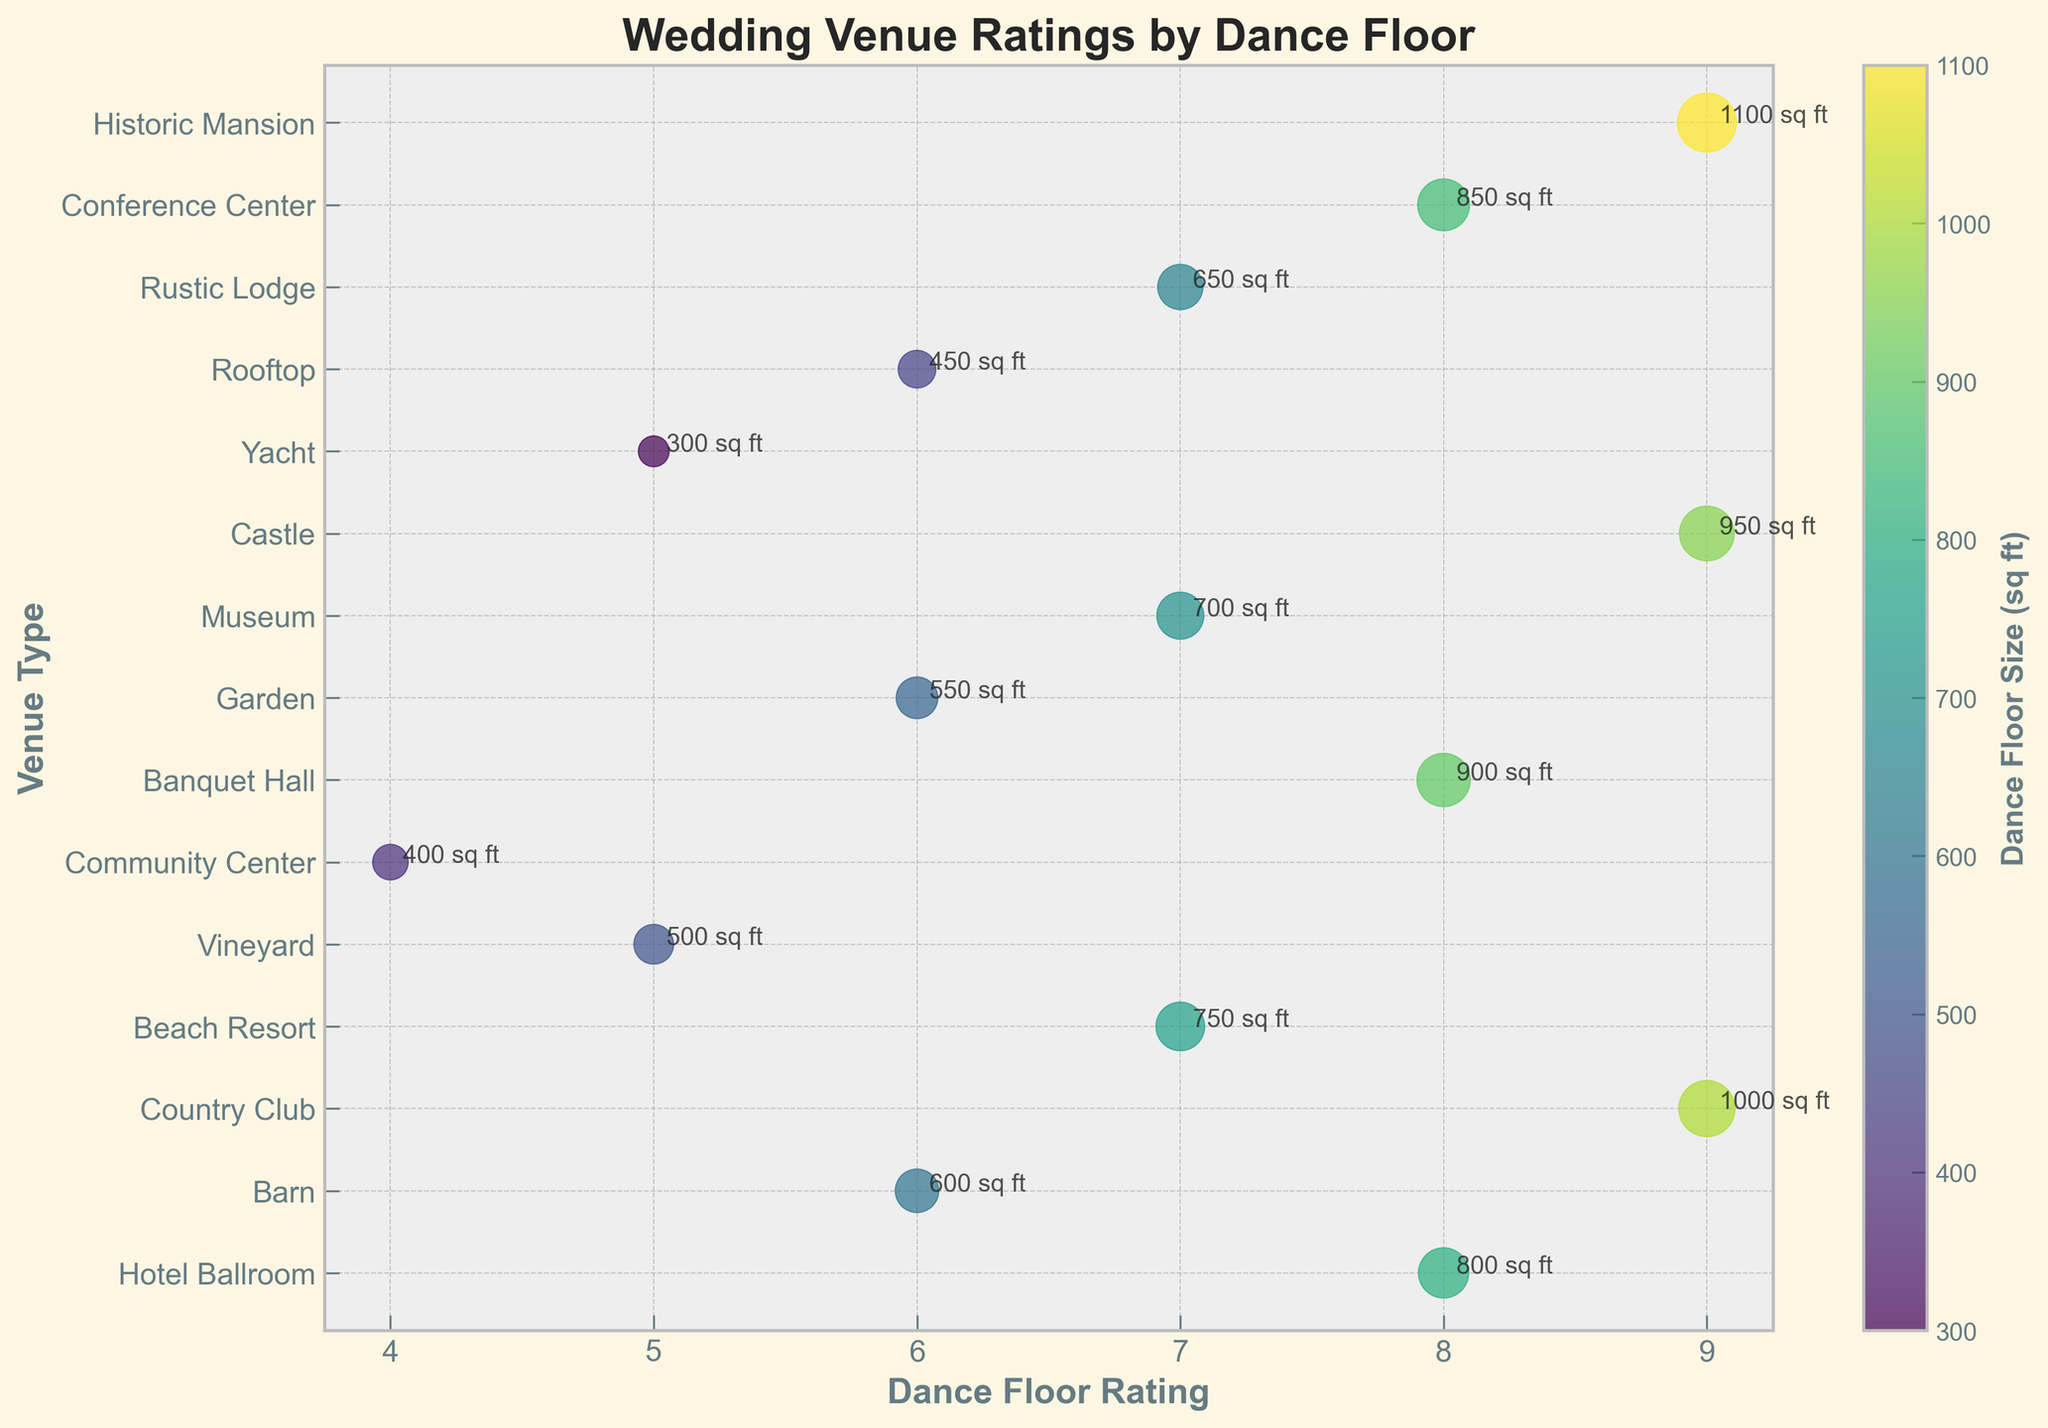What is the title of the figure? The title is typically located at the top of the figure for easy identification. Reading the title directly from the figure gives context about the data presented.
Answer: Wedding Venue Ratings by Dance Floor How many different venue types are shown in the plot? Count the number of unique entries along the y-axis, where venue types are listed.
Answer: 15 Which venue type has the highest dance floor rating? Look for the highest value on the x-axis (Dance Floor Rating) and identify the corresponding venue type on the y-axis.
Answer: Historic Mansion What is the size (sq ft) of the Castle's dance floor? Find "Castle" along the y-axis, then look at the color and size of the corresponding marker, and refer to the color bar or annotated text for the size.
Answer: 950 sq ft Which venue type has the smallest dance floor size and what is its rating? Identify the marker with the smallest size by comparing the marker sizes visually, then check the corresponding venue type and its rating.
Answer: Yacht, 5 How does the dance floor rating for Banquet Hall compare to that of Hotel Ballroom? Locate the Banquet Hall and Hotel Ballroom along the y-axis, then compare their respective positions on the x-axis.
Answer: Same (Rating of 8) What is the average dance floor rating of venues with sizes above 800 sq ft? Identify the venues with sizes above 800 sq ft by marker size or annotation, then average the ratings of these venues. 1: Castle (9), Country Club (9), Banquet Hall (8), Conference Center (8), Historic Mansion (9). 2: Sum these ratings: 9 + 9 + 8 + 8 + 9 = 43. 3: Count the venues: 5. 4: Calculate the average: 43 / 5 = 8.6.
Answer: 8.6 Which venue type has the closest dance floor size to 700 sq ft, and what is its rating? Identify the marker with a size close to 700 sq ft by referring to the color bar or annotation, then check the venue type and its rating.
Answer: Museum, 7 Do larger dance floors correlate with higher dance floor ratings? Visually compare the sizes (sq ft) and dance floor ratings by examining the overall trend: larger sizes should correspond to higher x-axis positions if there's a correlation. Many larger floors (Castle, Country Club, Historic Mansion) do have high ratings, suggesting a positive correlation.
Answer: Yes, generally Between venues with similar sizes (within 100 sq ft), which has the higher dance floor rating, Rustic Lodge or Garden? Identify the markers for Rustic Lodge and Garden, noting their sizes which should be within 100 sq ft range, then check their respective ratings on the x-axis.
Answer: Rustic Lodge (7 compared to 6 for Garden) 